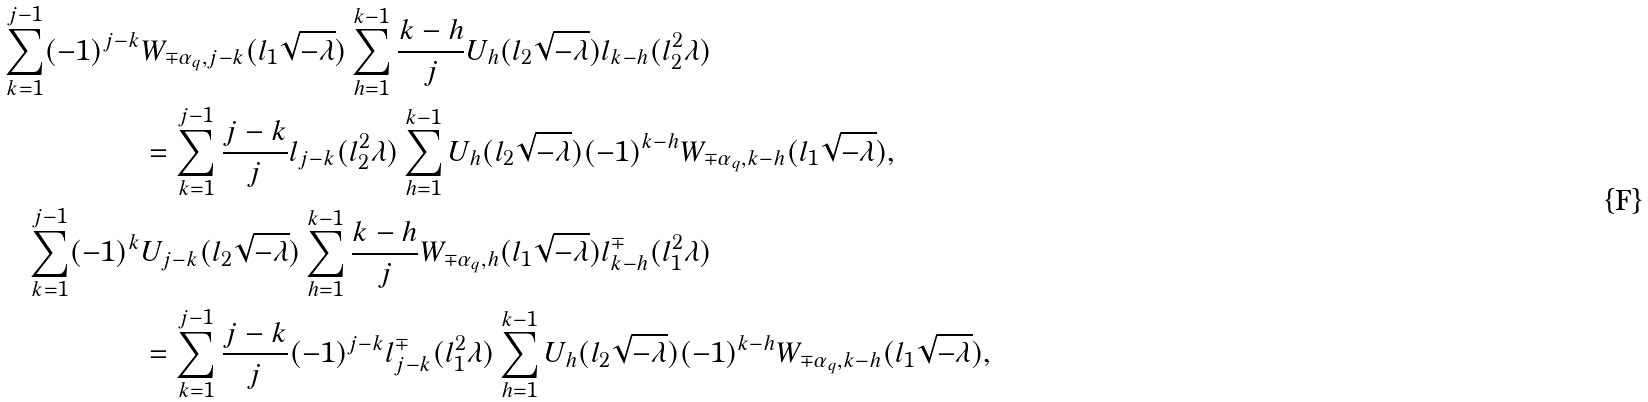<formula> <loc_0><loc_0><loc_500><loc_500>\sum _ { k = 1 } ^ { j - 1 } ( - 1 ) ^ { j - k } & W _ { \mp \alpha _ { q } , j - k } ( l _ { 1 } \sqrt { - \lambda } ) \sum _ { h = 1 } ^ { k - 1 } \frac { k - h } { j } U _ { h } ( l _ { 2 } \sqrt { - \lambda } ) l _ { k - h } ( l _ { 2 } ^ { 2 } \lambda ) \\ & = \sum _ { k = 1 } ^ { j - 1 } \frac { j - k } { j } l _ { j - k } ( l _ { 2 } ^ { 2 } \lambda ) \sum _ { h = 1 } ^ { k - 1 } U _ { h } ( l _ { 2 } \sqrt { - \lambda } ) ( - 1 ) ^ { k - h } W _ { \mp \alpha _ { q } , k - h } ( l _ { 1 } \sqrt { - \lambda } ) , \\ \sum _ { k = 1 } ^ { j - 1 } ( - 1 ) ^ { k } & U _ { j - k } ( l _ { 2 } \sqrt { - \lambda } ) \sum _ { h = 1 } ^ { k - 1 } \frac { k - h } { j } W _ { \mp \alpha _ { q } , h } ( l _ { 1 } \sqrt { - \lambda } ) l _ { k - h } ^ { \mp } ( l _ { 1 } ^ { 2 } \lambda ) \\ & = \sum _ { k = 1 } ^ { j - 1 } \frac { j - k } { j } ( - 1 ) ^ { j - k } l _ { j - k } ^ { \mp } ( l _ { 1 } ^ { 2 } \lambda ) \sum _ { h = 1 } ^ { k - 1 } U _ { h } ( l _ { 2 } \sqrt { - \lambda } ) ( - 1 ) ^ { k - h } W _ { \mp \alpha _ { q } , k - h } ( l _ { 1 } \sqrt { - \lambda } ) ,</formula> 